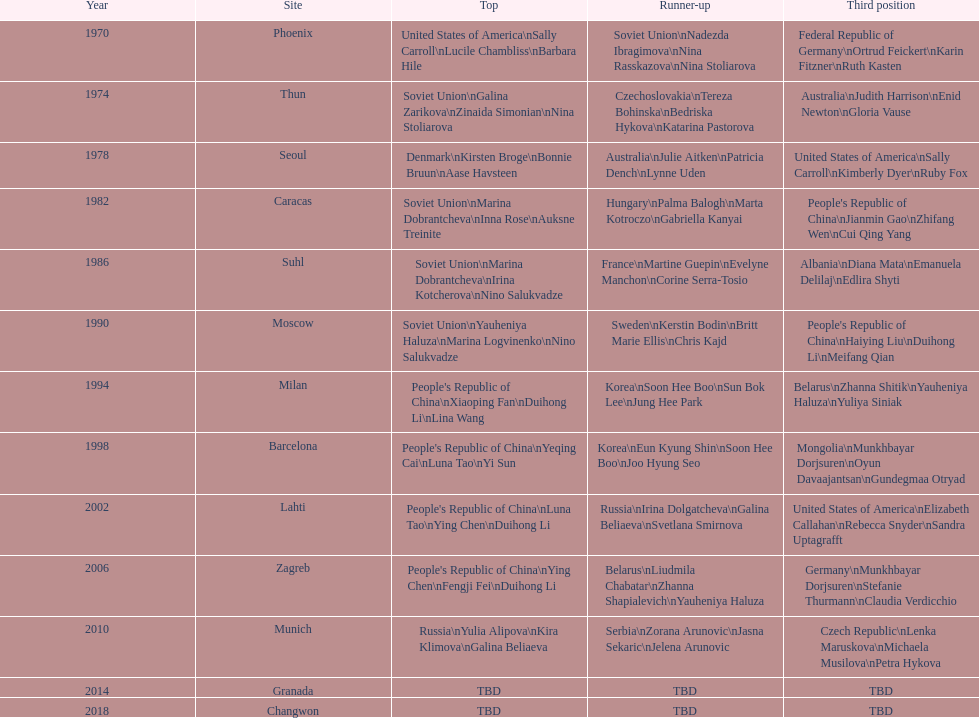What is the number of total bronze medals that germany has won? 1. 